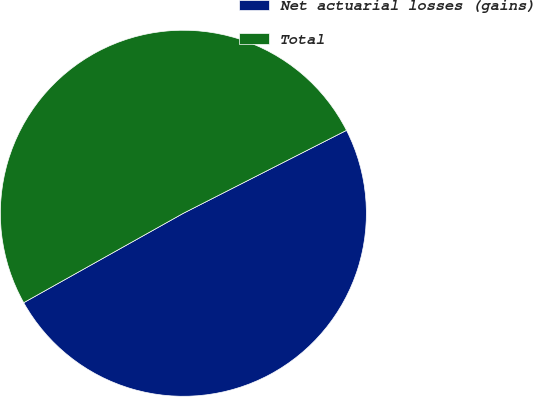Convert chart. <chart><loc_0><loc_0><loc_500><loc_500><pie_chart><fcel>Net actuarial losses (gains)<fcel>Total<nl><fcel>49.36%<fcel>50.64%<nl></chart> 